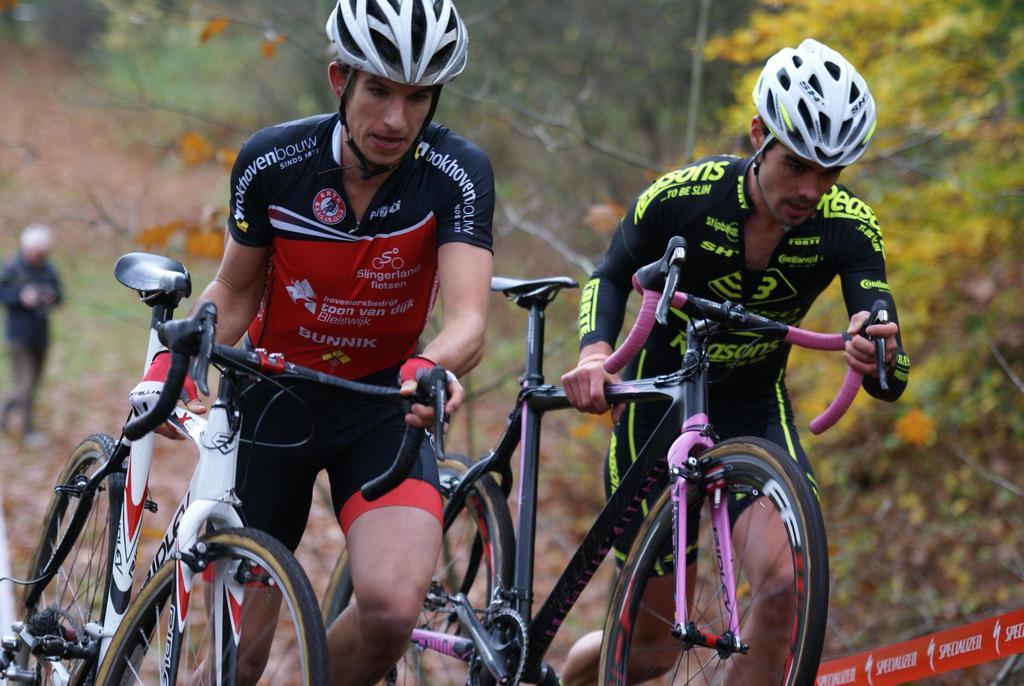In one or two sentences, can you explain what this image depicts? In this image I can see two persons holding bicycles, background I can see the other person standing and I can see few leaves in yellow color. 